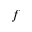Convert formula to latex. <formula><loc_0><loc_0><loc_500><loc_500>f</formula> 